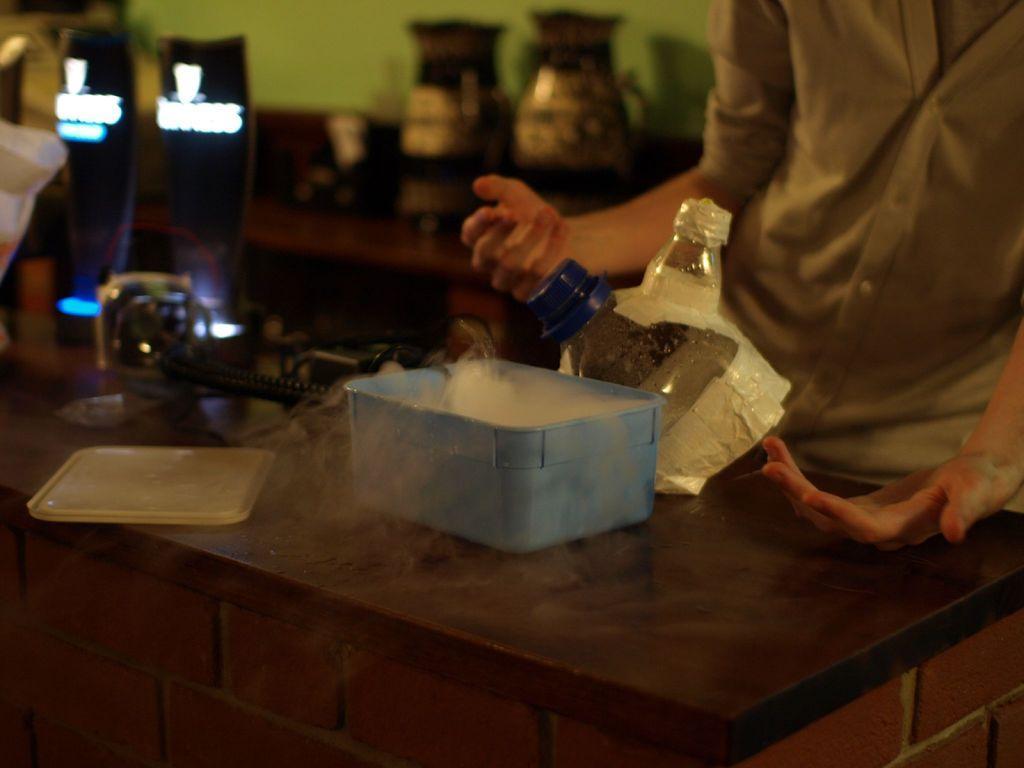In one or two sentences, can you explain what this image depicts? In this image, we can see a few tables with some objects like a container, a lid, bottles. We can also see a person and the wall. 